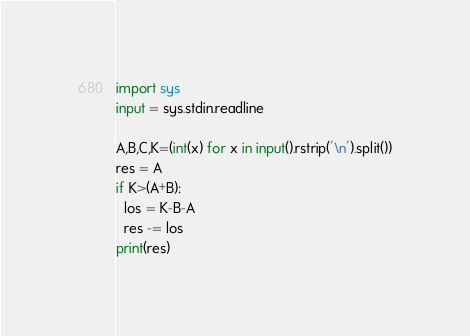Convert code to text. <code><loc_0><loc_0><loc_500><loc_500><_Python_>import sys
input = sys.stdin.readline

A,B,C,K=(int(x) for x in input().rstrip('\n').split())
res = A
if K>(A+B):
  los = K-B-A
  res -= los
print(res)</code> 